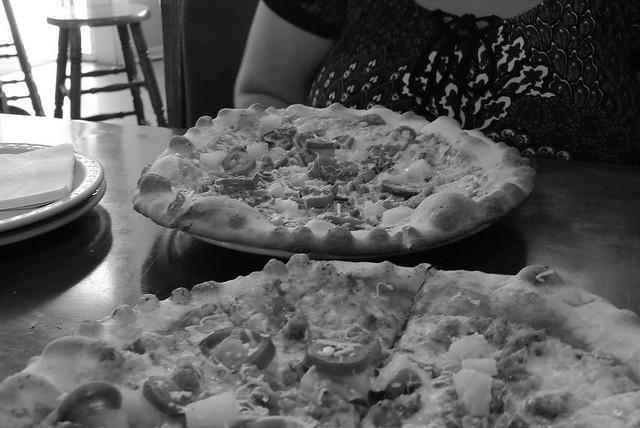Where was this food placed during cooking? oven 